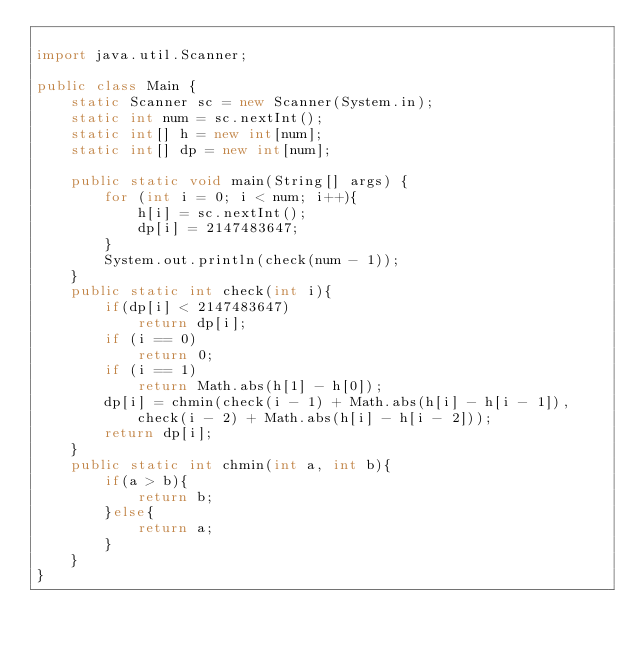Convert code to text. <code><loc_0><loc_0><loc_500><loc_500><_Java_>
import java.util.Scanner;

public class Main {
    static Scanner sc = new Scanner(System.in);
    static int num = sc.nextInt();
    static int[] h = new int[num];
    static int[] dp = new int[num];

    public static void main(String[] args) {
        for (int i = 0; i < num; i++){
            h[i] = sc.nextInt();
            dp[i] = 2147483647;
        }
        System.out.println(check(num - 1));
    }
    public static int check(int i){
        if(dp[i] < 2147483647)
            return dp[i];
        if (i == 0)
            return 0;
        if (i == 1)
            return Math.abs(h[1] - h[0]);
        dp[i] = chmin(check(i - 1) + Math.abs(h[i] - h[i - 1]), check(i - 2) + Math.abs(h[i] - h[i - 2]));
        return dp[i];
    }
    public static int chmin(int a, int b){
        if(a > b){
            return b;
        }else{
            return a;
        }
    }
}
</code> 